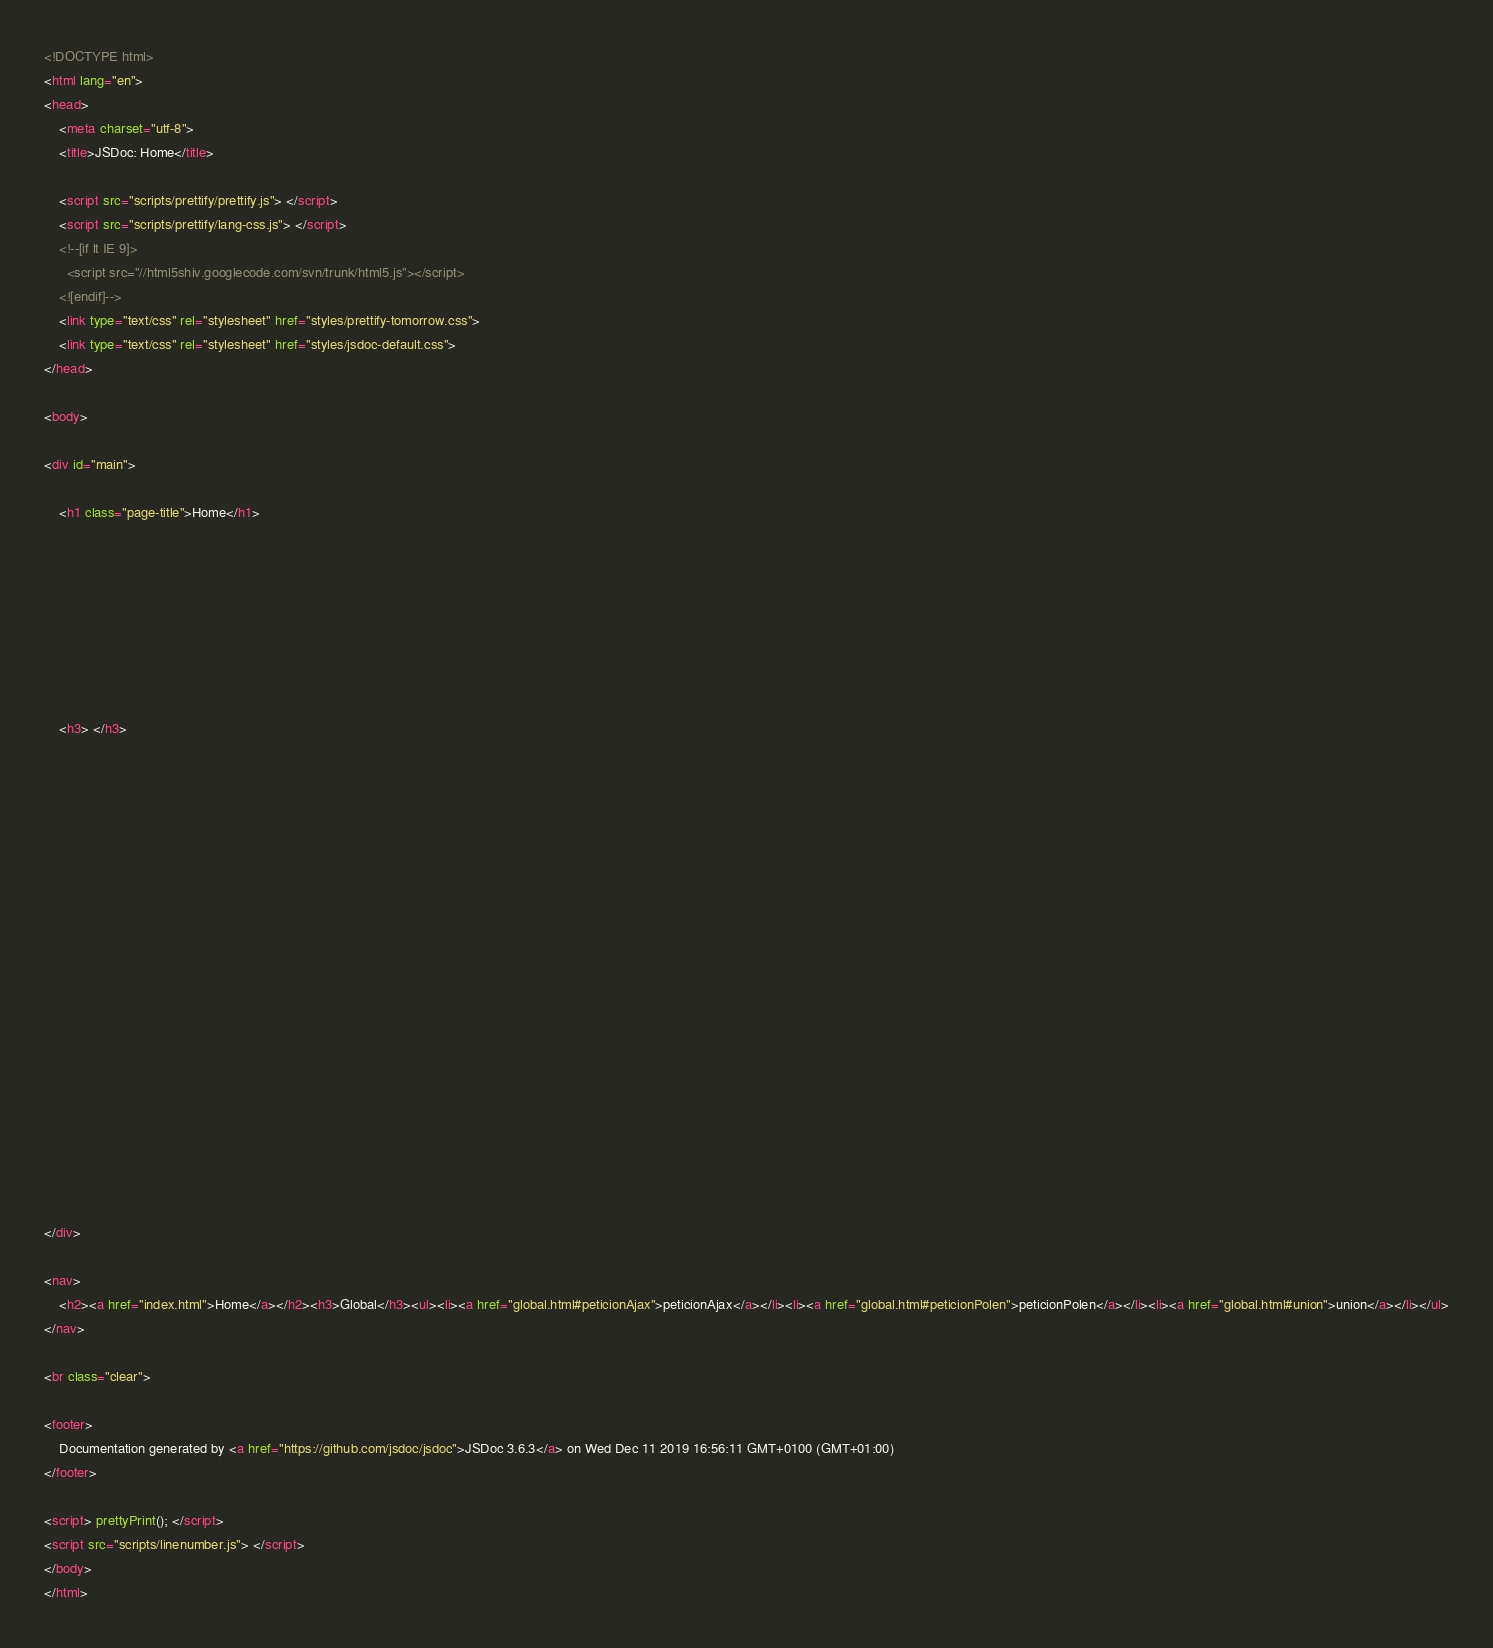<code> <loc_0><loc_0><loc_500><loc_500><_HTML_><!DOCTYPE html>
<html lang="en">
<head>
    <meta charset="utf-8">
    <title>JSDoc: Home</title>

    <script src="scripts/prettify/prettify.js"> </script>
    <script src="scripts/prettify/lang-css.js"> </script>
    <!--[if lt IE 9]>
      <script src="//html5shiv.googlecode.com/svn/trunk/html5.js"></script>
    <![endif]-->
    <link type="text/css" rel="stylesheet" href="styles/prettify-tomorrow.css">
    <link type="text/css" rel="stylesheet" href="styles/jsdoc-default.css">
</head>

<body>

<div id="main">

    <h1 class="page-title">Home</h1>

    



    


    <h3> </h3>










    









</div>

<nav>
    <h2><a href="index.html">Home</a></h2><h3>Global</h3><ul><li><a href="global.html#peticionAjax">peticionAjax</a></li><li><a href="global.html#peticionPolen">peticionPolen</a></li><li><a href="global.html#union">union</a></li></ul>
</nav>

<br class="clear">

<footer>
    Documentation generated by <a href="https://github.com/jsdoc/jsdoc">JSDoc 3.6.3</a> on Wed Dec 11 2019 16:56:11 GMT+0100 (GMT+01:00)
</footer>

<script> prettyPrint(); </script>
<script src="scripts/linenumber.js"> </script>
</body>
</html></code> 